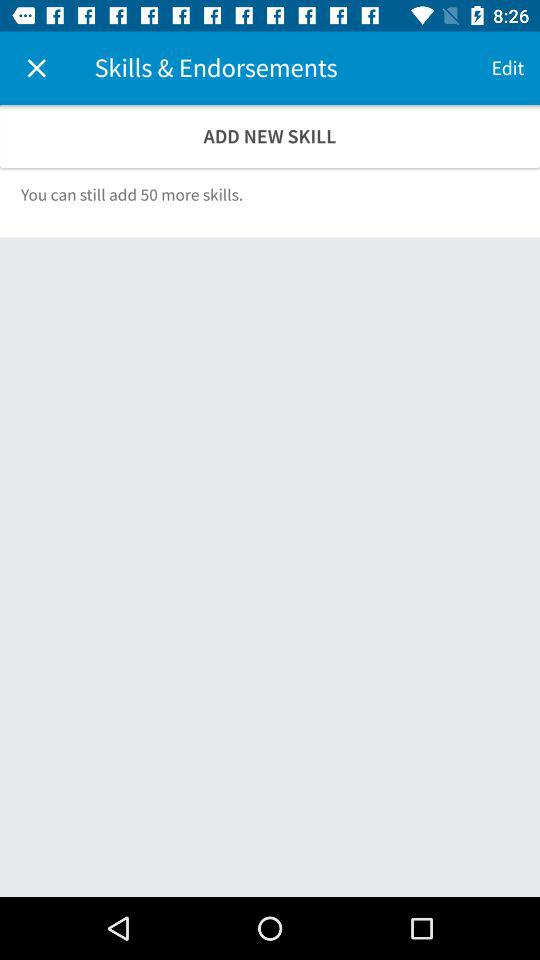How many skills can be added? There are 50 more skills that can be added. 